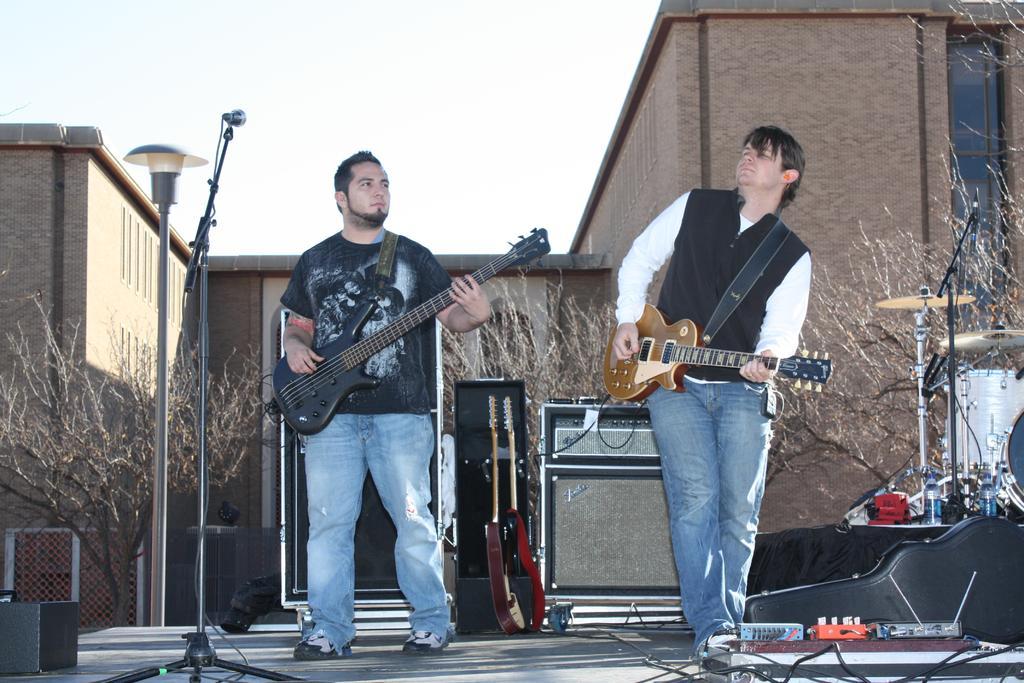Can you describe this image briefly? These two persons are playing guitar on the stage. Far there is a building. In-front of this building there are bare trees and fence. On this stage we can able to see mic, guitar box, cables, devices and bottles. At the left side of the image we can able to see musical instruments. This is pole with lamp. 